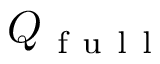<formula> <loc_0><loc_0><loc_500><loc_500>Q _ { f u l l }</formula> 